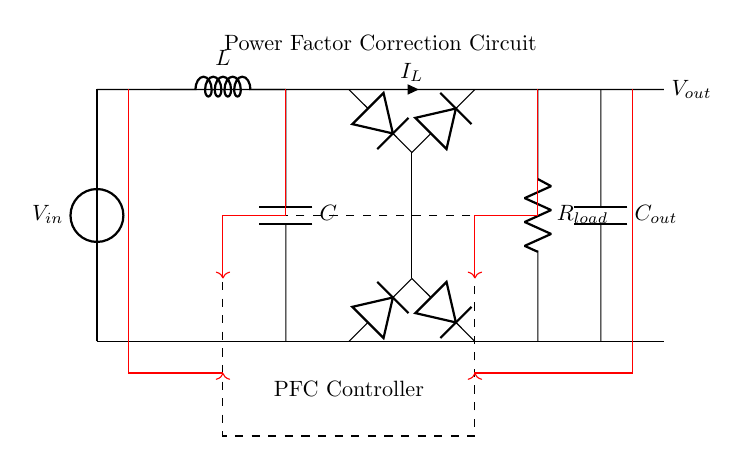What is the input voltage of the circuit? The input voltage is represented by the voltage source labeled as V_in, which is indicated at the top of the circuit diagram.
Answer: V_in What are the primary components in the power factor correction circuit? The primary components visible in the circuit include an inductor (L), a capacitor (C), a rectifier bridge (diodes), a load resistor (R_load), and an output capacitor (C_out).
Answer: Inverter, capacitor, diodes, load resistor What is the role of the PFC controller in the circuit? The PFC controller manages the power factor correction by regulating the voltage and current, thus improving the efficiency of the circuit. This function is indicated by the dashed rectangle labeled "PFC Controller" in the circuit diagram.
Answer: Manage power factor correction Where is the load resistor located in the circuit? The load resistor (R_load) is positioned on the right side of the circuit, connecting the top line to the bottom line, showing where the load is applied.
Answer: On the right side What type of circuit is presented in this diagram? The circuit is classified as a power factor correction circuit, specifically designed for industrial machinery in a manufacturing plant, focusing on improving efficiency.
Answer: Power factor correction circuit How does the output capacitor connect in the circuit? The output capacitor (C_out) is connected in parallel to the load resistor (R_load), facilitating the smoothing of voltage after the rectifier and ensuring steady output voltage.
Answer: In parallel with R_load What is the current direction in the circuit? The current, labeled as I_L, flows through the circuit from the voltage source V_in, through the inductor (L), rectifier bridge, load resistor (R_load), and the output capacitor (C_out).
Answer: From V_in through L to R_load 